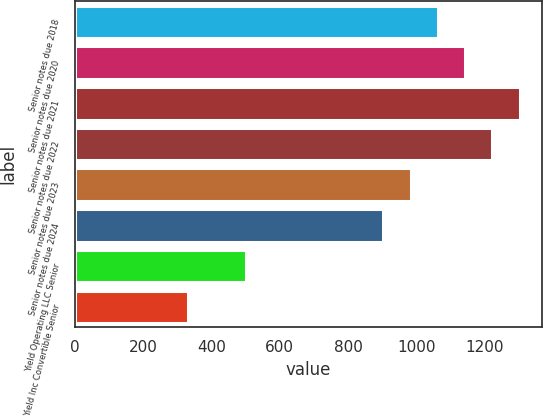Convert chart to OTSL. <chart><loc_0><loc_0><loc_500><loc_500><bar_chart><fcel>Senior notes due 2018<fcel>Senior notes due 2020<fcel>Senior notes due 2021<fcel>Senior notes due 2022<fcel>Senior notes due 2023<fcel>Senior notes due 2024<fcel>Yield Operating LLC Senior<fcel>Yield Inc Convertible Senior<nl><fcel>1063.6<fcel>1143.4<fcel>1303<fcel>1223.2<fcel>983.8<fcel>904<fcel>500<fcel>330<nl></chart> 